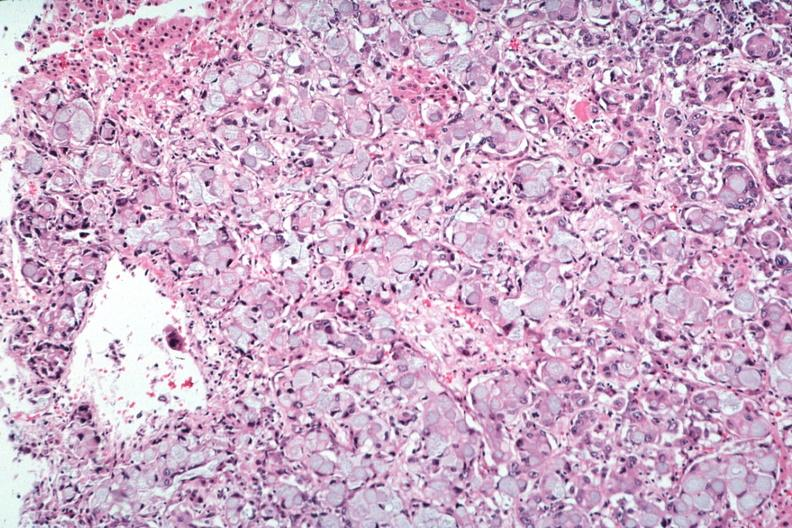s lesion of myocytolysis present?
Answer the question using a single word or phrase. No 